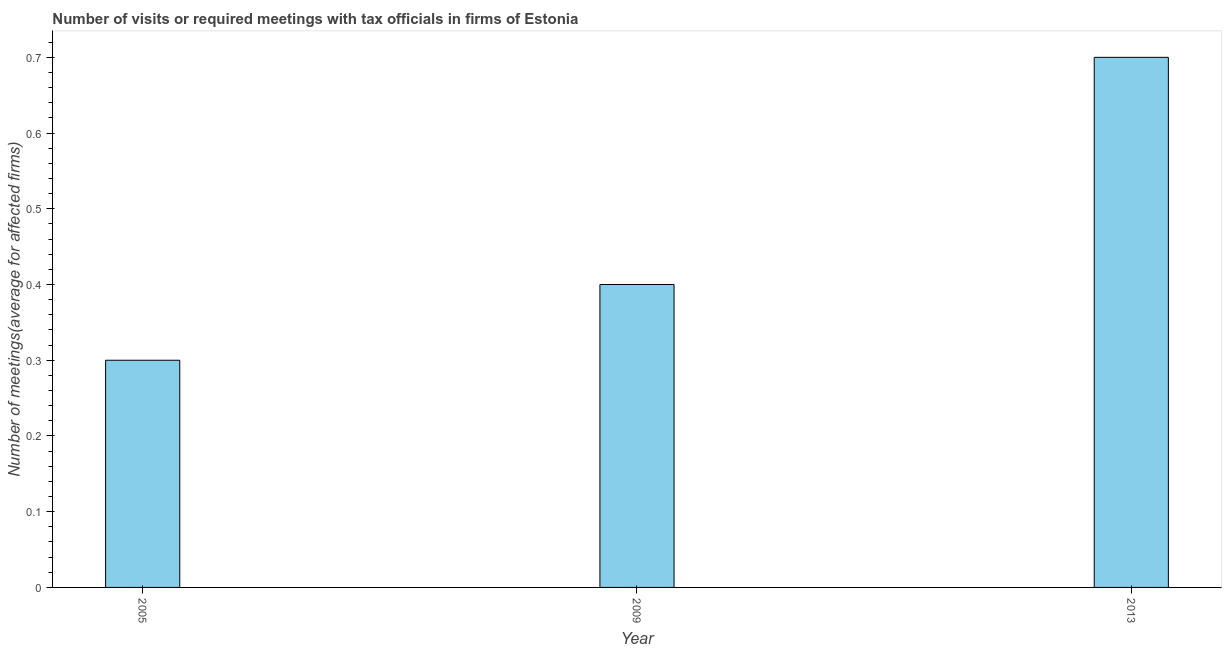Does the graph contain grids?
Your answer should be compact. No. What is the title of the graph?
Your answer should be compact. Number of visits or required meetings with tax officials in firms of Estonia. What is the label or title of the X-axis?
Your answer should be compact. Year. What is the label or title of the Y-axis?
Offer a terse response. Number of meetings(average for affected firms). Across all years, what is the minimum number of required meetings with tax officials?
Your response must be concise. 0.3. In which year was the number of required meetings with tax officials maximum?
Your answer should be very brief. 2013. In which year was the number of required meetings with tax officials minimum?
Provide a short and direct response. 2005. What is the sum of the number of required meetings with tax officials?
Make the answer very short. 1.4. What is the difference between the number of required meetings with tax officials in 2005 and 2009?
Provide a short and direct response. -0.1. What is the average number of required meetings with tax officials per year?
Your answer should be compact. 0.47. In how many years, is the number of required meetings with tax officials greater than 0.5 ?
Provide a succinct answer. 1. Is the difference between the number of required meetings with tax officials in 2005 and 2009 greater than the difference between any two years?
Ensure brevity in your answer.  No. In how many years, is the number of required meetings with tax officials greater than the average number of required meetings with tax officials taken over all years?
Make the answer very short. 1. What is the Number of meetings(average for affected firms) of 2005?
Offer a terse response. 0.3. What is the Number of meetings(average for affected firms) of 2013?
Offer a very short reply. 0.7. What is the difference between the Number of meetings(average for affected firms) in 2005 and 2009?
Provide a short and direct response. -0.1. What is the ratio of the Number of meetings(average for affected firms) in 2005 to that in 2009?
Offer a terse response. 0.75. What is the ratio of the Number of meetings(average for affected firms) in 2005 to that in 2013?
Make the answer very short. 0.43. What is the ratio of the Number of meetings(average for affected firms) in 2009 to that in 2013?
Make the answer very short. 0.57. 